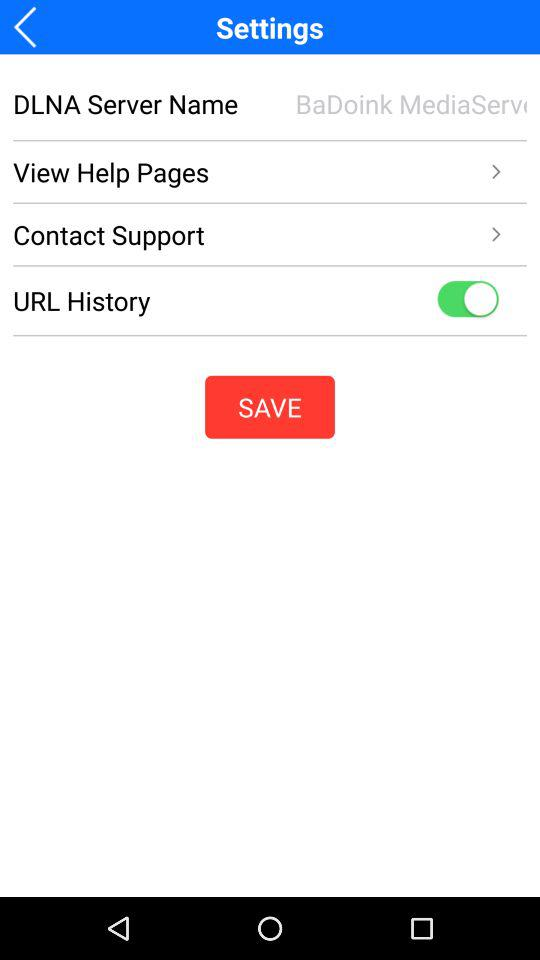What's the status of the "URL History"? The status is on. 